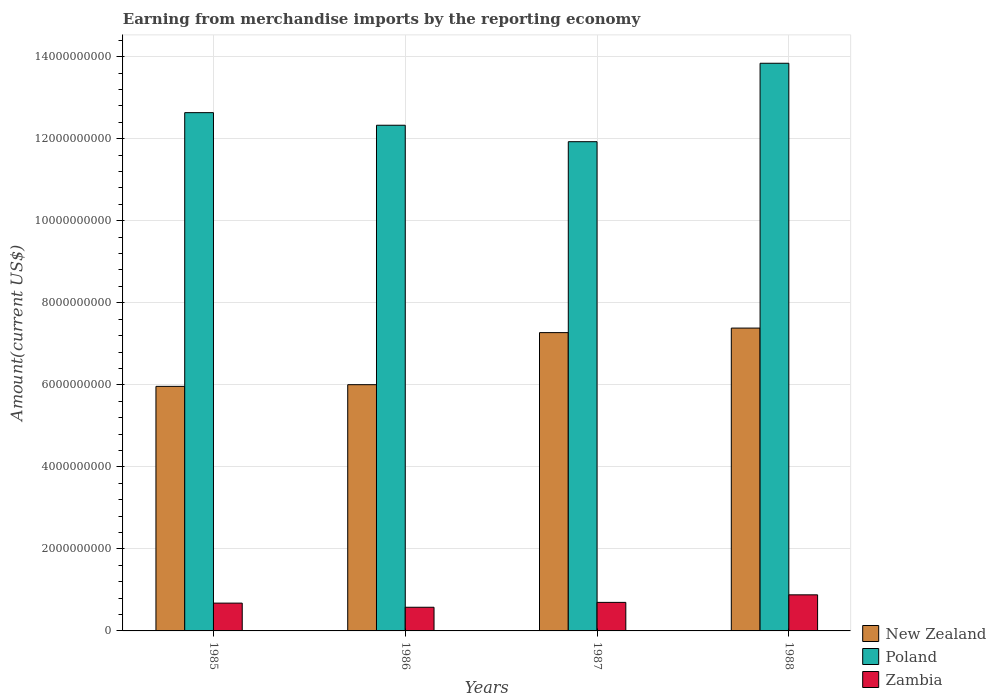Are the number of bars on each tick of the X-axis equal?
Your response must be concise. Yes. How many bars are there on the 3rd tick from the left?
Provide a succinct answer. 3. What is the amount earned from merchandise imports in Poland in 1988?
Give a very brief answer. 1.38e+1. Across all years, what is the maximum amount earned from merchandise imports in Poland?
Make the answer very short. 1.38e+1. Across all years, what is the minimum amount earned from merchandise imports in Poland?
Your answer should be compact. 1.19e+1. In which year was the amount earned from merchandise imports in Poland minimum?
Provide a succinct answer. 1987. What is the total amount earned from merchandise imports in Poland in the graph?
Offer a terse response. 5.07e+1. What is the difference between the amount earned from merchandise imports in Zambia in 1985 and that in 1986?
Ensure brevity in your answer.  1.01e+08. What is the difference between the amount earned from merchandise imports in New Zealand in 1986 and the amount earned from merchandise imports in Zambia in 1987?
Provide a short and direct response. 5.31e+09. What is the average amount earned from merchandise imports in Zambia per year?
Ensure brevity in your answer.  7.08e+08. In the year 1987, what is the difference between the amount earned from merchandise imports in Poland and amount earned from merchandise imports in Zambia?
Make the answer very short. 1.12e+1. What is the ratio of the amount earned from merchandise imports in Zambia in 1986 to that in 1987?
Offer a terse response. 0.83. Is the amount earned from merchandise imports in Zambia in 1985 less than that in 1987?
Your response must be concise. Yes. Is the difference between the amount earned from merchandise imports in Poland in 1985 and 1988 greater than the difference between the amount earned from merchandise imports in Zambia in 1985 and 1988?
Your answer should be compact. No. What is the difference between the highest and the second highest amount earned from merchandise imports in Poland?
Offer a terse response. 1.20e+09. What is the difference between the highest and the lowest amount earned from merchandise imports in Poland?
Keep it short and to the point. 1.91e+09. In how many years, is the amount earned from merchandise imports in Zambia greater than the average amount earned from merchandise imports in Zambia taken over all years?
Provide a succinct answer. 1. What does the 2nd bar from the left in 1985 represents?
Provide a short and direct response. Poland. How many years are there in the graph?
Provide a succinct answer. 4. Are the values on the major ticks of Y-axis written in scientific E-notation?
Your answer should be very brief. No. Does the graph contain any zero values?
Give a very brief answer. No. Does the graph contain grids?
Keep it short and to the point. Yes. How many legend labels are there?
Your response must be concise. 3. How are the legend labels stacked?
Keep it short and to the point. Vertical. What is the title of the graph?
Provide a succinct answer. Earning from merchandise imports by the reporting economy. Does "Hungary" appear as one of the legend labels in the graph?
Keep it short and to the point. No. What is the label or title of the Y-axis?
Provide a succinct answer. Amount(current US$). What is the Amount(current US$) in New Zealand in 1985?
Offer a terse response. 5.96e+09. What is the Amount(current US$) of Poland in 1985?
Ensure brevity in your answer.  1.26e+1. What is the Amount(current US$) in Zambia in 1985?
Provide a short and direct response. 6.78e+08. What is the Amount(current US$) of New Zealand in 1986?
Your answer should be compact. 6.00e+09. What is the Amount(current US$) of Poland in 1986?
Provide a succinct answer. 1.23e+1. What is the Amount(current US$) of Zambia in 1986?
Your answer should be very brief. 5.77e+08. What is the Amount(current US$) in New Zealand in 1987?
Offer a terse response. 7.27e+09. What is the Amount(current US$) of Poland in 1987?
Give a very brief answer. 1.19e+1. What is the Amount(current US$) in Zambia in 1987?
Ensure brevity in your answer.  6.96e+08. What is the Amount(current US$) of New Zealand in 1988?
Offer a very short reply. 7.38e+09. What is the Amount(current US$) in Poland in 1988?
Give a very brief answer. 1.38e+1. What is the Amount(current US$) in Zambia in 1988?
Offer a terse response. 8.80e+08. Across all years, what is the maximum Amount(current US$) of New Zealand?
Make the answer very short. 7.38e+09. Across all years, what is the maximum Amount(current US$) in Poland?
Offer a very short reply. 1.38e+1. Across all years, what is the maximum Amount(current US$) in Zambia?
Your answer should be very brief. 8.80e+08. Across all years, what is the minimum Amount(current US$) in New Zealand?
Ensure brevity in your answer.  5.96e+09. Across all years, what is the minimum Amount(current US$) in Poland?
Offer a very short reply. 1.19e+1. Across all years, what is the minimum Amount(current US$) of Zambia?
Make the answer very short. 5.77e+08. What is the total Amount(current US$) in New Zealand in the graph?
Offer a very short reply. 2.66e+1. What is the total Amount(current US$) of Poland in the graph?
Offer a terse response. 5.07e+1. What is the total Amount(current US$) of Zambia in the graph?
Your response must be concise. 2.83e+09. What is the difference between the Amount(current US$) of New Zealand in 1985 and that in 1986?
Make the answer very short. -4.11e+07. What is the difference between the Amount(current US$) of Poland in 1985 and that in 1986?
Make the answer very short. 3.07e+08. What is the difference between the Amount(current US$) in Zambia in 1985 and that in 1986?
Keep it short and to the point. 1.01e+08. What is the difference between the Amount(current US$) in New Zealand in 1985 and that in 1987?
Provide a succinct answer. -1.31e+09. What is the difference between the Amount(current US$) in Poland in 1985 and that in 1987?
Ensure brevity in your answer.  7.08e+08. What is the difference between the Amount(current US$) of Zambia in 1985 and that in 1987?
Give a very brief answer. -1.81e+07. What is the difference between the Amount(current US$) in New Zealand in 1985 and that in 1988?
Provide a short and direct response. -1.42e+09. What is the difference between the Amount(current US$) of Poland in 1985 and that in 1988?
Offer a very short reply. -1.20e+09. What is the difference between the Amount(current US$) in Zambia in 1985 and that in 1988?
Make the answer very short. -2.02e+08. What is the difference between the Amount(current US$) of New Zealand in 1986 and that in 1987?
Your response must be concise. -1.27e+09. What is the difference between the Amount(current US$) in Poland in 1986 and that in 1987?
Provide a succinct answer. 4.01e+08. What is the difference between the Amount(current US$) in Zambia in 1986 and that in 1987?
Offer a very short reply. -1.19e+08. What is the difference between the Amount(current US$) of New Zealand in 1986 and that in 1988?
Offer a very short reply. -1.38e+09. What is the difference between the Amount(current US$) of Poland in 1986 and that in 1988?
Keep it short and to the point. -1.51e+09. What is the difference between the Amount(current US$) of Zambia in 1986 and that in 1988?
Offer a very short reply. -3.03e+08. What is the difference between the Amount(current US$) in New Zealand in 1987 and that in 1988?
Keep it short and to the point. -1.10e+08. What is the difference between the Amount(current US$) in Poland in 1987 and that in 1988?
Offer a very short reply. -1.91e+09. What is the difference between the Amount(current US$) of Zambia in 1987 and that in 1988?
Give a very brief answer. -1.84e+08. What is the difference between the Amount(current US$) of New Zealand in 1985 and the Amount(current US$) of Poland in 1986?
Your answer should be compact. -6.37e+09. What is the difference between the Amount(current US$) of New Zealand in 1985 and the Amount(current US$) of Zambia in 1986?
Your answer should be very brief. 5.39e+09. What is the difference between the Amount(current US$) in Poland in 1985 and the Amount(current US$) in Zambia in 1986?
Your response must be concise. 1.21e+1. What is the difference between the Amount(current US$) of New Zealand in 1985 and the Amount(current US$) of Poland in 1987?
Offer a terse response. -5.97e+09. What is the difference between the Amount(current US$) of New Zealand in 1985 and the Amount(current US$) of Zambia in 1987?
Your answer should be very brief. 5.27e+09. What is the difference between the Amount(current US$) of Poland in 1985 and the Amount(current US$) of Zambia in 1987?
Keep it short and to the point. 1.19e+1. What is the difference between the Amount(current US$) in New Zealand in 1985 and the Amount(current US$) in Poland in 1988?
Ensure brevity in your answer.  -7.88e+09. What is the difference between the Amount(current US$) of New Zealand in 1985 and the Amount(current US$) of Zambia in 1988?
Provide a succinct answer. 5.08e+09. What is the difference between the Amount(current US$) in Poland in 1985 and the Amount(current US$) in Zambia in 1988?
Your answer should be very brief. 1.18e+1. What is the difference between the Amount(current US$) of New Zealand in 1986 and the Amount(current US$) of Poland in 1987?
Your answer should be compact. -5.92e+09. What is the difference between the Amount(current US$) in New Zealand in 1986 and the Amount(current US$) in Zambia in 1987?
Make the answer very short. 5.31e+09. What is the difference between the Amount(current US$) of Poland in 1986 and the Amount(current US$) of Zambia in 1987?
Give a very brief answer. 1.16e+1. What is the difference between the Amount(current US$) of New Zealand in 1986 and the Amount(current US$) of Poland in 1988?
Give a very brief answer. -7.84e+09. What is the difference between the Amount(current US$) of New Zealand in 1986 and the Amount(current US$) of Zambia in 1988?
Provide a succinct answer. 5.12e+09. What is the difference between the Amount(current US$) in Poland in 1986 and the Amount(current US$) in Zambia in 1988?
Provide a short and direct response. 1.14e+1. What is the difference between the Amount(current US$) of New Zealand in 1987 and the Amount(current US$) of Poland in 1988?
Provide a succinct answer. -6.57e+09. What is the difference between the Amount(current US$) of New Zealand in 1987 and the Amount(current US$) of Zambia in 1988?
Provide a short and direct response. 6.39e+09. What is the difference between the Amount(current US$) of Poland in 1987 and the Amount(current US$) of Zambia in 1988?
Provide a short and direct response. 1.10e+1. What is the average Amount(current US$) in New Zealand per year?
Your answer should be compact. 6.66e+09. What is the average Amount(current US$) in Poland per year?
Provide a succinct answer. 1.27e+1. What is the average Amount(current US$) in Zambia per year?
Give a very brief answer. 7.08e+08. In the year 1985, what is the difference between the Amount(current US$) in New Zealand and Amount(current US$) in Poland?
Ensure brevity in your answer.  -6.67e+09. In the year 1985, what is the difference between the Amount(current US$) of New Zealand and Amount(current US$) of Zambia?
Your answer should be very brief. 5.28e+09. In the year 1985, what is the difference between the Amount(current US$) in Poland and Amount(current US$) in Zambia?
Your response must be concise. 1.20e+1. In the year 1986, what is the difference between the Amount(current US$) of New Zealand and Amount(current US$) of Poland?
Provide a short and direct response. -6.33e+09. In the year 1986, what is the difference between the Amount(current US$) in New Zealand and Amount(current US$) in Zambia?
Make the answer very short. 5.43e+09. In the year 1986, what is the difference between the Amount(current US$) of Poland and Amount(current US$) of Zambia?
Your answer should be very brief. 1.18e+1. In the year 1987, what is the difference between the Amount(current US$) of New Zealand and Amount(current US$) of Poland?
Offer a terse response. -4.65e+09. In the year 1987, what is the difference between the Amount(current US$) in New Zealand and Amount(current US$) in Zambia?
Keep it short and to the point. 6.58e+09. In the year 1987, what is the difference between the Amount(current US$) of Poland and Amount(current US$) of Zambia?
Ensure brevity in your answer.  1.12e+1. In the year 1988, what is the difference between the Amount(current US$) of New Zealand and Amount(current US$) of Poland?
Give a very brief answer. -6.46e+09. In the year 1988, what is the difference between the Amount(current US$) of New Zealand and Amount(current US$) of Zambia?
Your response must be concise. 6.50e+09. In the year 1988, what is the difference between the Amount(current US$) of Poland and Amount(current US$) of Zambia?
Provide a succinct answer. 1.30e+1. What is the ratio of the Amount(current US$) of New Zealand in 1985 to that in 1986?
Make the answer very short. 0.99. What is the ratio of the Amount(current US$) in Poland in 1985 to that in 1986?
Give a very brief answer. 1.02. What is the ratio of the Amount(current US$) in Zambia in 1985 to that in 1986?
Ensure brevity in your answer.  1.17. What is the ratio of the Amount(current US$) of New Zealand in 1985 to that in 1987?
Your response must be concise. 0.82. What is the ratio of the Amount(current US$) of Poland in 1985 to that in 1987?
Offer a terse response. 1.06. What is the ratio of the Amount(current US$) of Zambia in 1985 to that in 1987?
Provide a short and direct response. 0.97. What is the ratio of the Amount(current US$) of New Zealand in 1985 to that in 1988?
Offer a terse response. 0.81. What is the ratio of the Amount(current US$) in Poland in 1985 to that in 1988?
Offer a terse response. 0.91. What is the ratio of the Amount(current US$) in Zambia in 1985 to that in 1988?
Ensure brevity in your answer.  0.77. What is the ratio of the Amount(current US$) of New Zealand in 1986 to that in 1987?
Ensure brevity in your answer.  0.83. What is the ratio of the Amount(current US$) of Poland in 1986 to that in 1987?
Give a very brief answer. 1.03. What is the ratio of the Amount(current US$) in Zambia in 1986 to that in 1987?
Your answer should be very brief. 0.83. What is the ratio of the Amount(current US$) of New Zealand in 1986 to that in 1988?
Your response must be concise. 0.81. What is the ratio of the Amount(current US$) of Poland in 1986 to that in 1988?
Offer a terse response. 0.89. What is the ratio of the Amount(current US$) in Zambia in 1986 to that in 1988?
Your answer should be very brief. 0.66. What is the ratio of the Amount(current US$) in New Zealand in 1987 to that in 1988?
Keep it short and to the point. 0.99. What is the ratio of the Amount(current US$) of Poland in 1987 to that in 1988?
Provide a succinct answer. 0.86. What is the ratio of the Amount(current US$) in Zambia in 1987 to that in 1988?
Your response must be concise. 0.79. What is the difference between the highest and the second highest Amount(current US$) in New Zealand?
Make the answer very short. 1.10e+08. What is the difference between the highest and the second highest Amount(current US$) of Poland?
Provide a succinct answer. 1.20e+09. What is the difference between the highest and the second highest Amount(current US$) in Zambia?
Give a very brief answer. 1.84e+08. What is the difference between the highest and the lowest Amount(current US$) in New Zealand?
Provide a short and direct response. 1.42e+09. What is the difference between the highest and the lowest Amount(current US$) in Poland?
Provide a short and direct response. 1.91e+09. What is the difference between the highest and the lowest Amount(current US$) in Zambia?
Offer a terse response. 3.03e+08. 